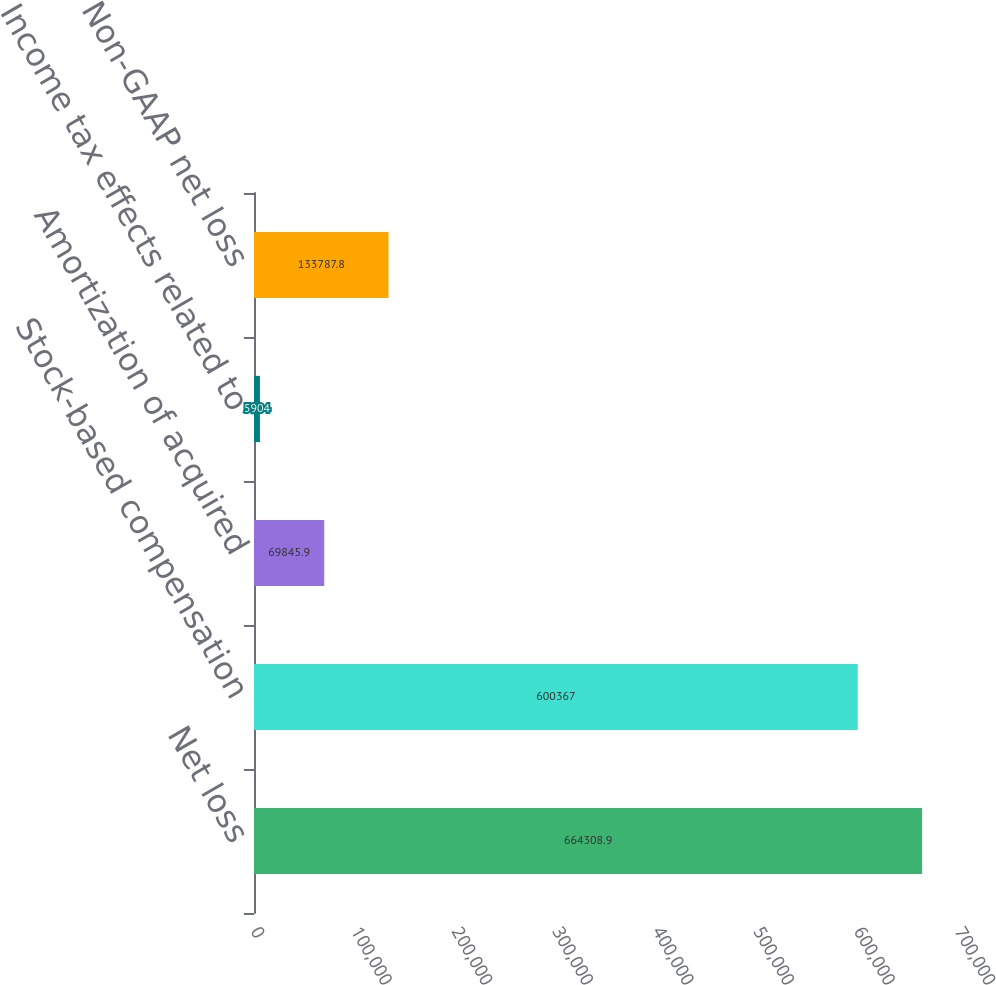Convert chart to OTSL. <chart><loc_0><loc_0><loc_500><loc_500><bar_chart><fcel>Net loss<fcel>Stock-based compensation<fcel>Amortization of acquired<fcel>Income tax effects related to<fcel>Non-GAAP net loss<nl><fcel>664309<fcel>600367<fcel>69845.9<fcel>5904<fcel>133788<nl></chart> 